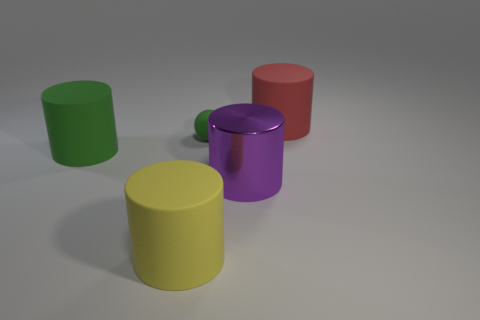Add 3 yellow things. How many objects exist? 8 Subtract all spheres. How many objects are left? 4 Subtract 0 cyan cylinders. How many objects are left? 5 Subtract all big purple objects. Subtract all big green cylinders. How many objects are left? 3 Add 5 big yellow rubber cylinders. How many big yellow rubber cylinders are left? 6 Add 5 large purple metal cylinders. How many large purple metal cylinders exist? 6 